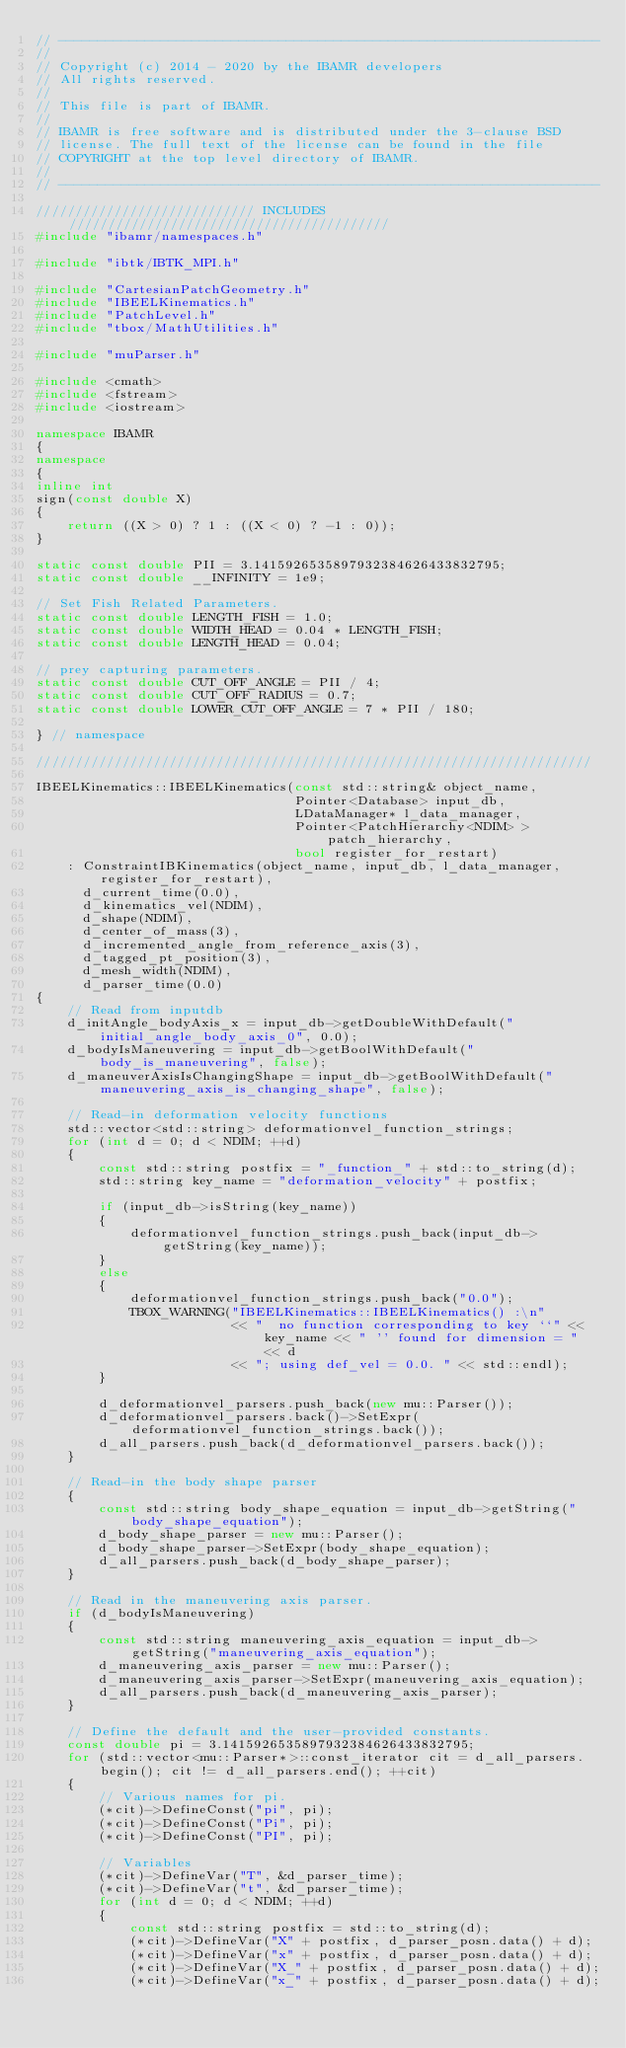Convert code to text. <code><loc_0><loc_0><loc_500><loc_500><_C++_>// ---------------------------------------------------------------------
//
// Copyright (c) 2014 - 2020 by the IBAMR developers
// All rights reserved.
//
// This file is part of IBAMR.
//
// IBAMR is free software and is distributed under the 3-clause BSD
// license. The full text of the license can be found in the file
// COPYRIGHT at the top level directory of IBAMR.
//
// ---------------------------------------------------------------------

//////////////////////////// INCLUDES /////////////////////////////////////////
#include "ibamr/namespaces.h"

#include "ibtk/IBTK_MPI.h"

#include "CartesianPatchGeometry.h"
#include "IBEELKinematics.h"
#include "PatchLevel.h"
#include "tbox/MathUtilities.h"

#include "muParser.h"

#include <cmath>
#include <fstream>
#include <iostream>

namespace IBAMR
{
namespace
{
inline int
sign(const double X)
{
    return ((X > 0) ? 1 : ((X < 0) ? -1 : 0));
}

static const double PII = 3.1415926535897932384626433832795;
static const double __INFINITY = 1e9;

// Set Fish Related Parameters.
static const double LENGTH_FISH = 1.0;
static const double WIDTH_HEAD = 0.04 * LENGTH_FISH;
static const double LENGTH_HEAD = 0.04;

// prey capturing parameters.
static const double CUT_OFF_ANGLE = PII / 4;
static const double CUT_OFF_RADIUS = 0.7;
static const double LOWER_CUT_OFF_ANGLE = 7 * PII / 180;

} // namespace

///////////////////////////////////////////////////////////////////////

IBEELKinematics::IBEELKinematics(const std::string& object_name,
                                 Pointer<Database> input_db,
                                 LDataManager* l_data_manager,
                                 Pointer<PatchHierarchy<NDIM> > patch_hierarchy,
                                 bool register_for_restart)
    : ConstraintIBKinematics(object_name, input_db, l_data_manager, register_for_restart),
      d_current_time(0.0),
      d_kinematics_vel(NDIM),
      d_shape(NDIM),
      d_center_of_mass(3),
      d_incremented_angle_from_reference_axis(3),
      d_tagged_pt_position(3),
      d_mesh_width(NDIM),
      d_parser_time(0.0)
{
    // Read from inputdb
    d_initAngle_bodyAxis_x = input_db->getDoubleWithDefault("initial_angle_body_axis_0", 0.0);
    d_bodyIsManeuvering = input_db->getBoolWithDefault("body_is_maneuvering", false);
    d_maneuverAxisIsChangingShape = input_db->getBoolWithDefault("maneuvering_axis_is_changing_shape", false);

    // Read-in deformation velocity functions
    std::vector<std::string> deformationvel_function_strings;
    for (int d = 0; d < NDIM; ++d)
    {
        const std::string postfix = "_function_" + std::to_string(d);
        std::string key_name = "deformation_velocity" + postfix;

        if (input_db->isString(key_name))
        {
            deformationvel_function_strings.push_back(input_db->getString(key_name));
        }
        else
        {
            deformationvel_function_strings.push_back("0.0");
            TBOX_WARNING("IBEELKinematics::IBEELKinematics() :\n"
                         << "  no function corresponding to key ``" << key_name << " '' found for dimension = " << d
                         << "; using def_vel = 0.0. " << std::endl);
        }

        d_deformationvel_parsers.push_back(new mu::Parser());
        d_deformationvel_parsers.back()->SetExpr(deformationvel_function_strings.back());
        d_all_parsers.push_back(d_deformationvel_parsers.back());
    }

    // Read-in the body shape parser
    {
        const std::string body_shape_equation = input_db->getString("body_shape_equation");
        d_body_shape_parser = new mu::Parser();
        d_body_shape_parser->SetExpr(body_shape_equation);
        d_all_parsers.push_back(d_body_shape_parser);
    }

    // Read in the maneuvering axis parser.
    if (d_bodyIsManeuvering)
    {
        const std::string maneuvering_axis_equation = input_db->getString("maneuvering_axis_equation");
        d_maneuvering_axis_parser = new mu::Parser();
        d_maneuvering_axis_parser->SetExpr(maneuvering_axis_equation);
        d_all_parsers.push_back(d_maneuvering_axis_parser);
    }

    // Define the default and the user-provided constants.
    const double pi = 3.1415926535897932384626433832795;
    for (std::vector<mu::Parser*>::const_iterator cit = d_all_parsers.begin(); cit != d_all_parsers.end(); ++cit)
    {
        // Various names for pi.
        (*cit)->DefineConst("pi", pi);
        (*cit)->DefineConst("Pi", pi);
        (*cit)->DefineConst("PI", pi);

        // Variables
        (*cit)->DefineVar("T", &d_parser_time);
        (*cit)->DefineVar("t", &d_parser_time);
        for (int d = 0; d < NDIM; ++d)
        {
            const std::string postfix = std::to_string(d);
            (*cit)->DefineVar("X" + postfix, d_parser_posn.data() + d);
            (*cit)->DefineVar("x" + postfix, d_parser_posn.data() + d);
            (*cit)->DefineVar("X_" + postfix, d_parser_posn.data() + d);
            (*cit)->DefineVar("x_" + postfix, d_parser_posn.data() + d);
</code> 